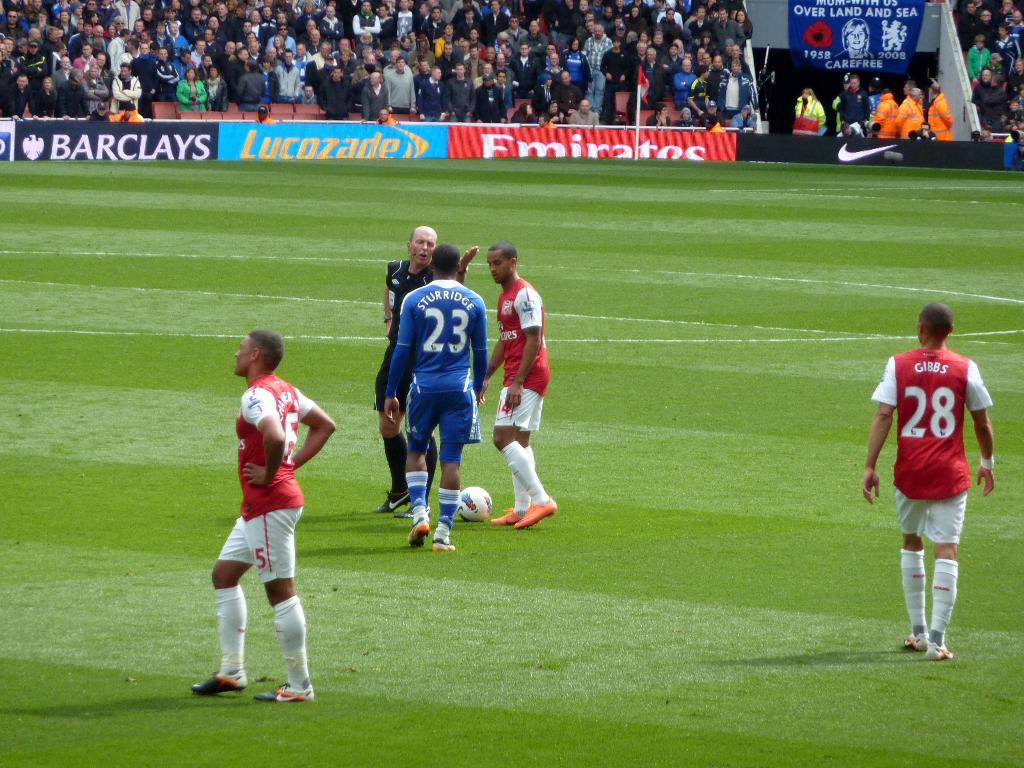Provide a one-sentence caption for the provided image. Sturridge, number 23, talks with the referee in a soccer match. 